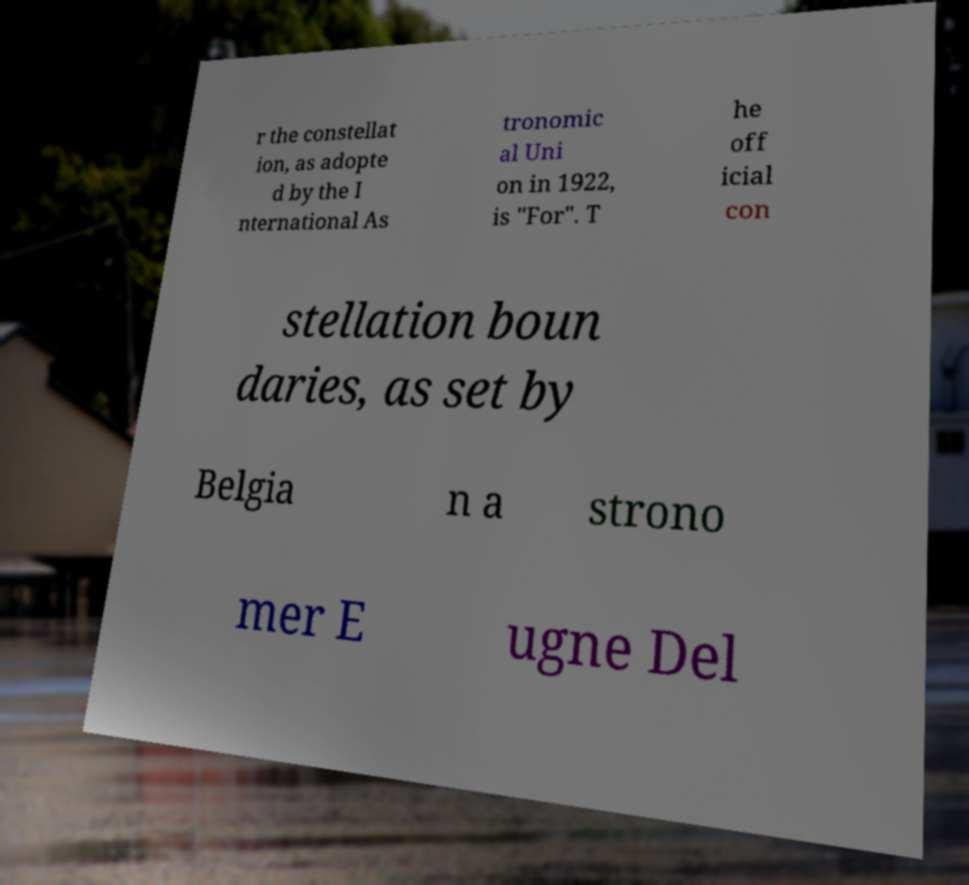Can you accurately transcribe the text from the provided image for me? r the constellat ion, as adopte d by the I nternational As tronomic al Uni on in 1922, is "For". T he off icial con stellation boun daries, as set by Belgia n a strono mer E ugne Del 